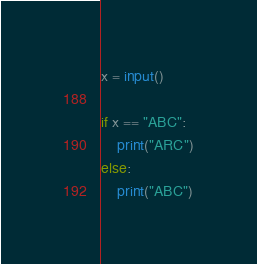Convert code to text. <code><loc_0><loc_0><loc_500><loc_500><_Python_>x = input()

if x == "ABC":
    print("ARC")
else:
    print("ABC")</code> 